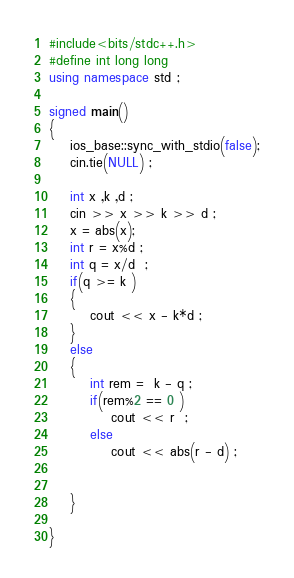<code> <loc_0><loc_0><loc_500><loc_500><_C++_>#include<bits/stdc++.h>
#define int long long
using namespace std ;

signed main()
{
	ios_base::sync_with_stdio(false);
	cin.tie(NULL) ;
	
	int x ,k ,d ; 
	cin >> x >> k >> d ; 
	x = abs(x);
	int r = x%d ; 
	int q = x/d  ;
	if(q >= k )
	{
		cout << x - k*d ; 
	}
	else 
	{
		int rem =  k - q ; 
		if(rem%2 == 0 )
			cout << r  ;
		else 
			cout << abs(r - d) ; 


	}

}    

</code> 